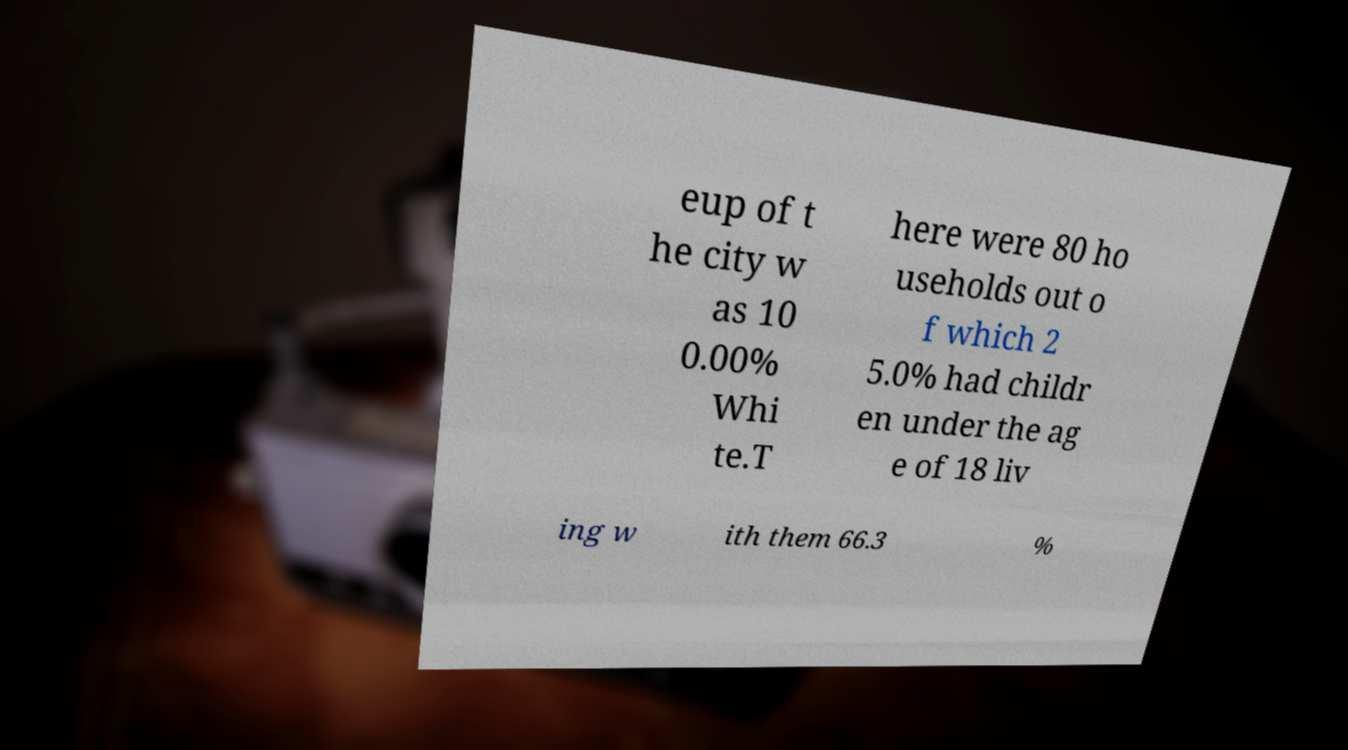Please read and relay the text visible in this image. What does it say? eup of t he city w as 10 0.00% Whi te.T here were 80 ho useholds out o f which 2 5.0% had childr en under the ag e of 18 liv ing w ith them 66.3 % 